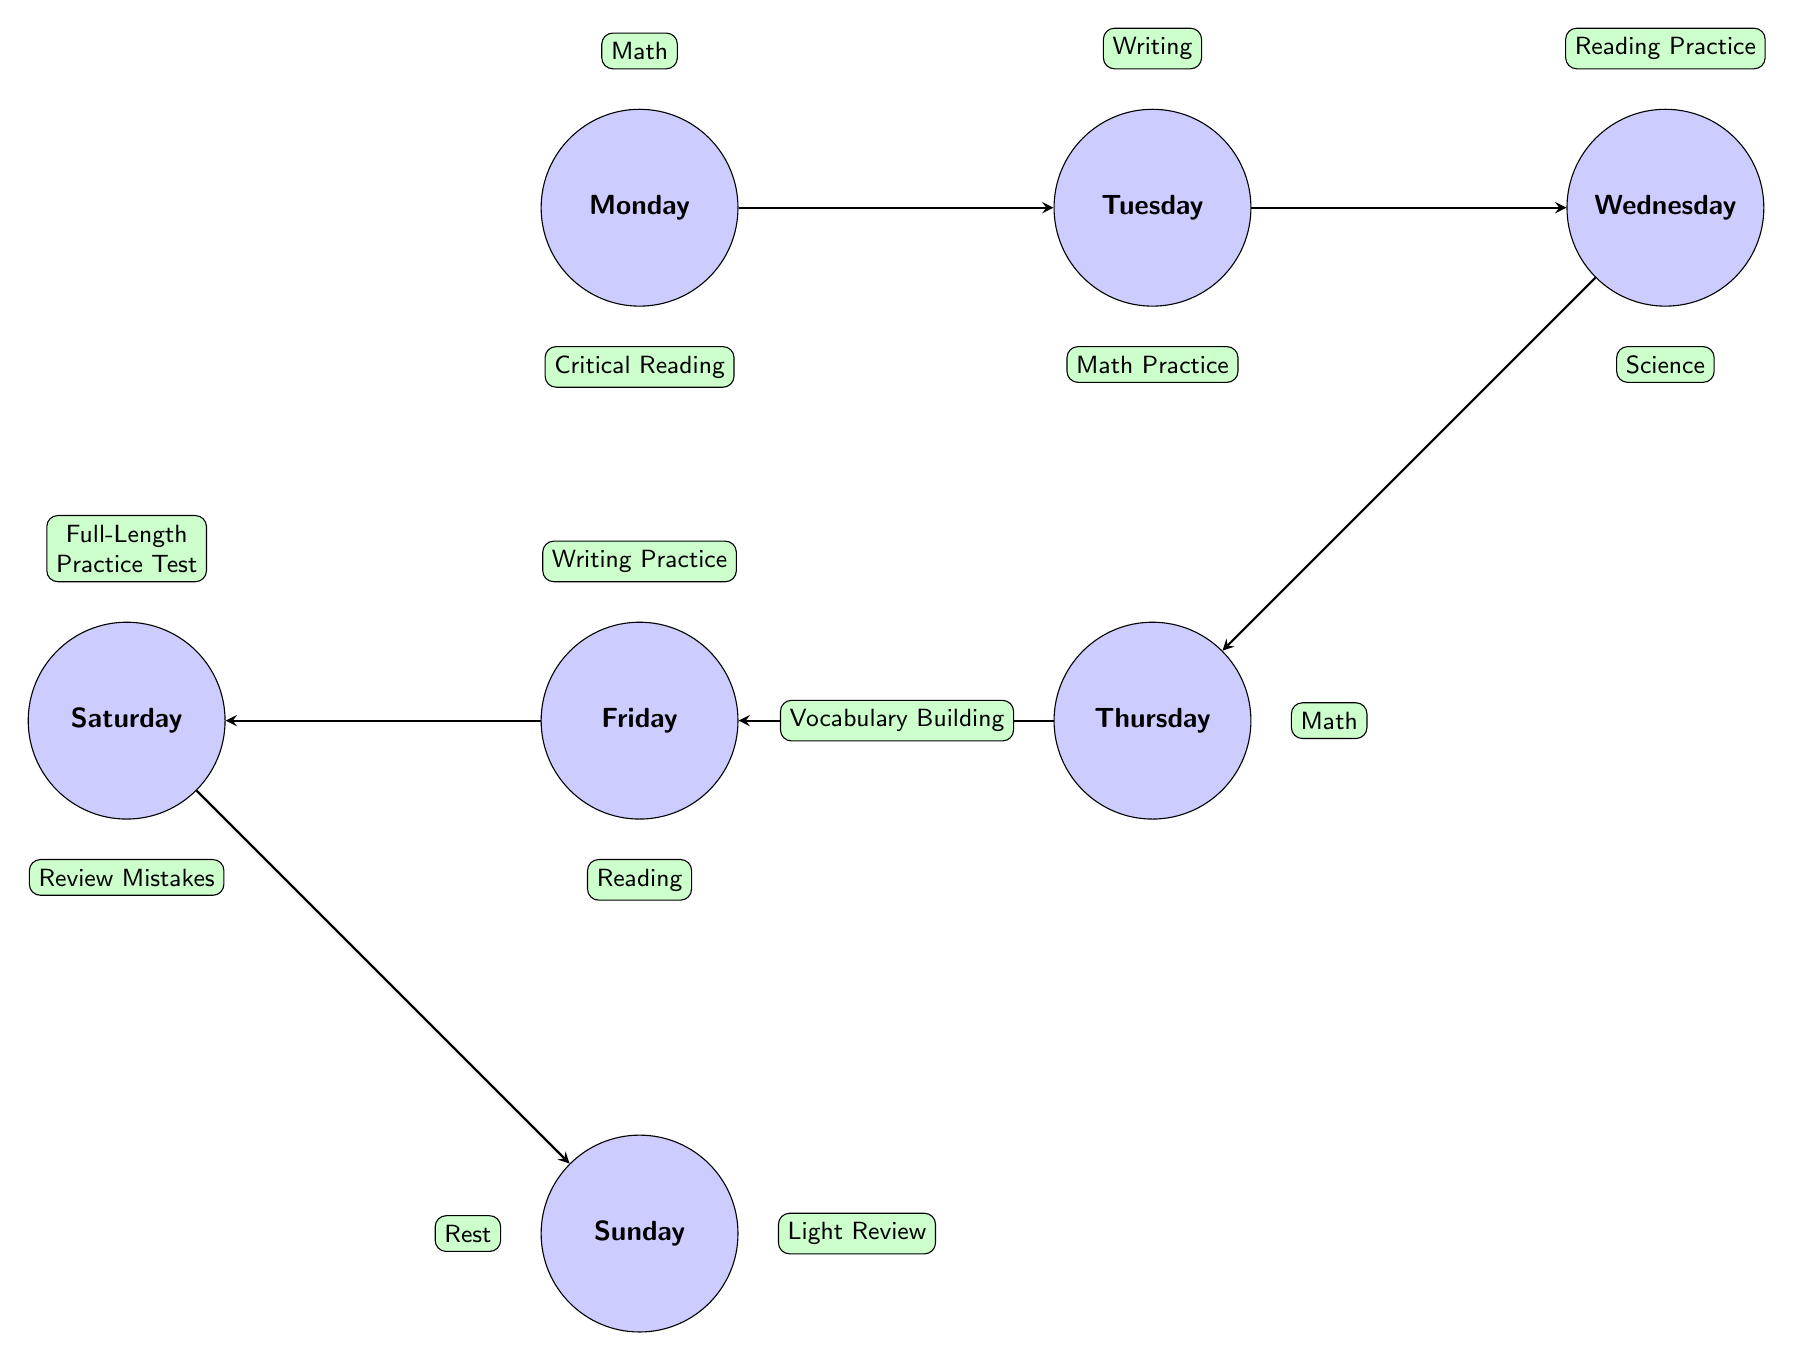What subjects are scheduled for Monday? The diagram shows two subjects for Monday: Math, positioned above the day node, and Critical Reading, positioned below it.
Answer: Math, Critical Reading How many main study days are represented in the diagram? The diagram displays seven day nodes, which represent the main study days of the week from Monday through Sunday.
Answer: 7 Which subject is paired with Writing on Tuesday? On Tuesday, the subject connected above is Writing, and below it is Math Practice. Therefore, Writing pairs with Math Practice.
Answer: Math Practice What activity is planned for Saturday? Saturday includes two activities: a Full-Length Practice Test above the day node and a Review Mistakes below it, indicating that both activities are part of the schedule for that day.
Answer: Full-Length Practice Test, Review Mistakes What is the connection between Thursday's subjects? Thursday features Vocabulary Building and Math. Vocabulary Building is positioned to the left of the node and Math is on the right, indicating both subjects are scheduled for Thursday, making them related as part of the same day's study.
Answer: Vocabulary Building, Math What subject follows Monday in the weekly schedule? The arrow leads from Monday to Tuesday, indicating the sequence of study days. Thus, the following day after Monday is Tuesday.
Answer: Tuesday What is the focus of the study session on Sunday? On Sunday, the diagram indicates a focus on two activities: Light Review and Rest. Light Review is positioned to the right and Rest to the left, showing that both are planned for that day.
Answer: Light Review, Rest Which subject is repeated most frequently throughout the week? Examining the subjects across all days, Math appears three times: on Monday, Tuesday, and Thursday, indicating it is the most frequently studied subject in this schedule.
Answer: Math 